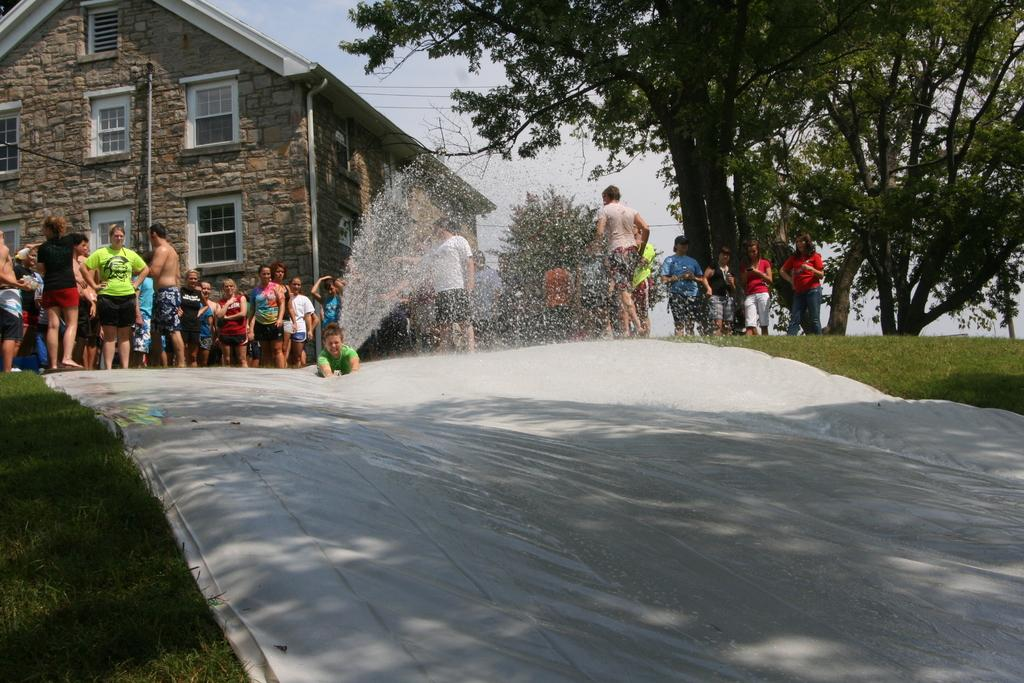How many people are in the image? There is a group of people standing in the image. What is at the bottom of the image? There is grass at the bottom of the image. What is the weather like in the image? There appears to be snow in the image. What can be seen in the background of the image? There are houses, trees, and wires in the background of the image. Where is the toothpaste located in the image? There is no toothpaste present in the image. How many kittens are playing with the man in the image? There are no kittens or man present in the image. 